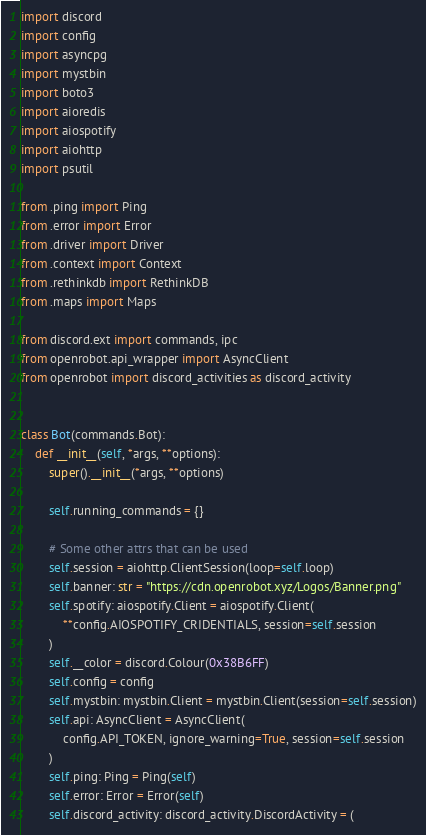Convert code to text. <code><loc_0><loc_0><loc_500><loc_500><_Python_>import discord
import config
import asyncpg
import mystbin
import boto3
import aioredis
import aiospotify
import aiohttp
import psutil

from .ping import Ping
from .error import Error
from .driver import Driver
from .context import Context
from .rethinkdb import RethinkDB
from .maps import Maps

from discord.ext import commands, ipc
from openrobot.api_wrapper import AsyncClient
from openrobot import discord_activities as discord_activity


class Bot(commands.Bot):
    def __init__(self, *args, **options):
        super().__init__(*args, **options)

        self.running_commands = {}

        # Some other attrs that can be used
        self.session = aiohttp.ClientSession(loop=self.loop)
        self.banner: str = "https://cdn.openrobot.xyz/Logos/Banner.png"
        self.spotify: aiospotify.Client = aiospotify.Client(
            **config.AIOSPOTIFY_CRIDENTIALS, session=self.session
        )
        self.__color = discord.Colour(0x38B6FF)
        self.config = config
        self.mystbin: mystbin.Client = mystbin.Client(session=self.session)
        self.api: AsyncClient = AsyncClient(
            config.API_TOKEN, ignore_warning=True, session=self.session
        )
        self.ping: Ping = Ping(self)
        self.error: Error = Error(self)
        self.discord_activity: discord_activity.DiscordActivity = (</code> 